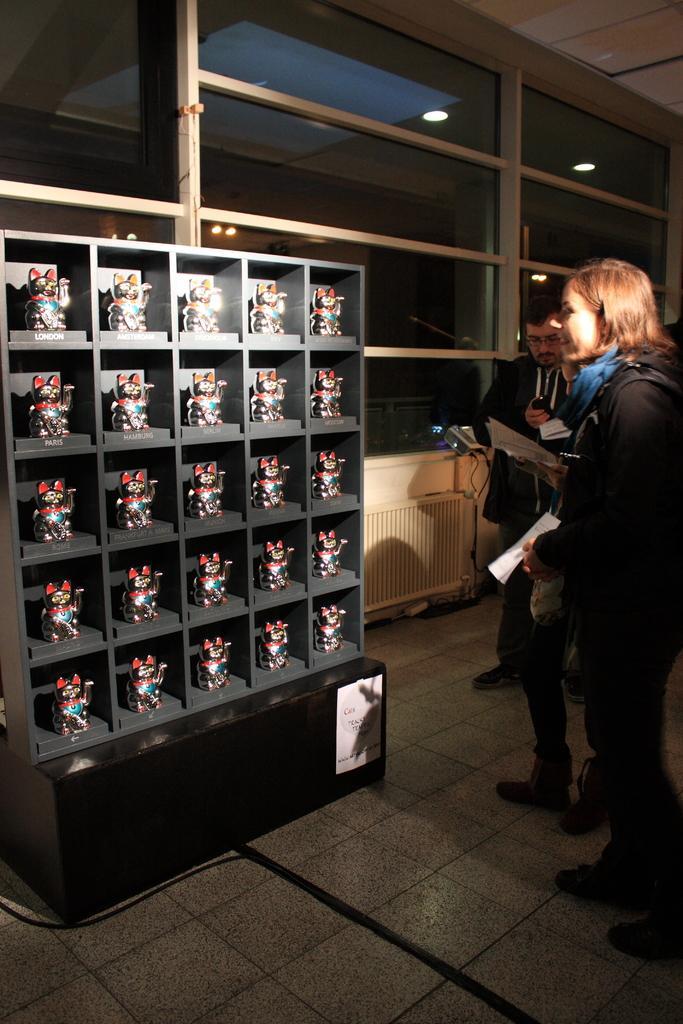Please provide a concise description of this image. In this image on the right side there are some persons who are standing, and they are holding some papers and on the left side there is one cupboard. In that cupboard there are some toys, and in the background there are some glass windows and wall and some lights. At the bottom there is floor, and at the top there is ceiling. 